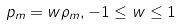Convert formula to latex. <formula><loc_0><loc_0><loc_500><loc_500>p _ { m } = w \rho _ { m } , - 1 \leq w \leq 1</formula> 